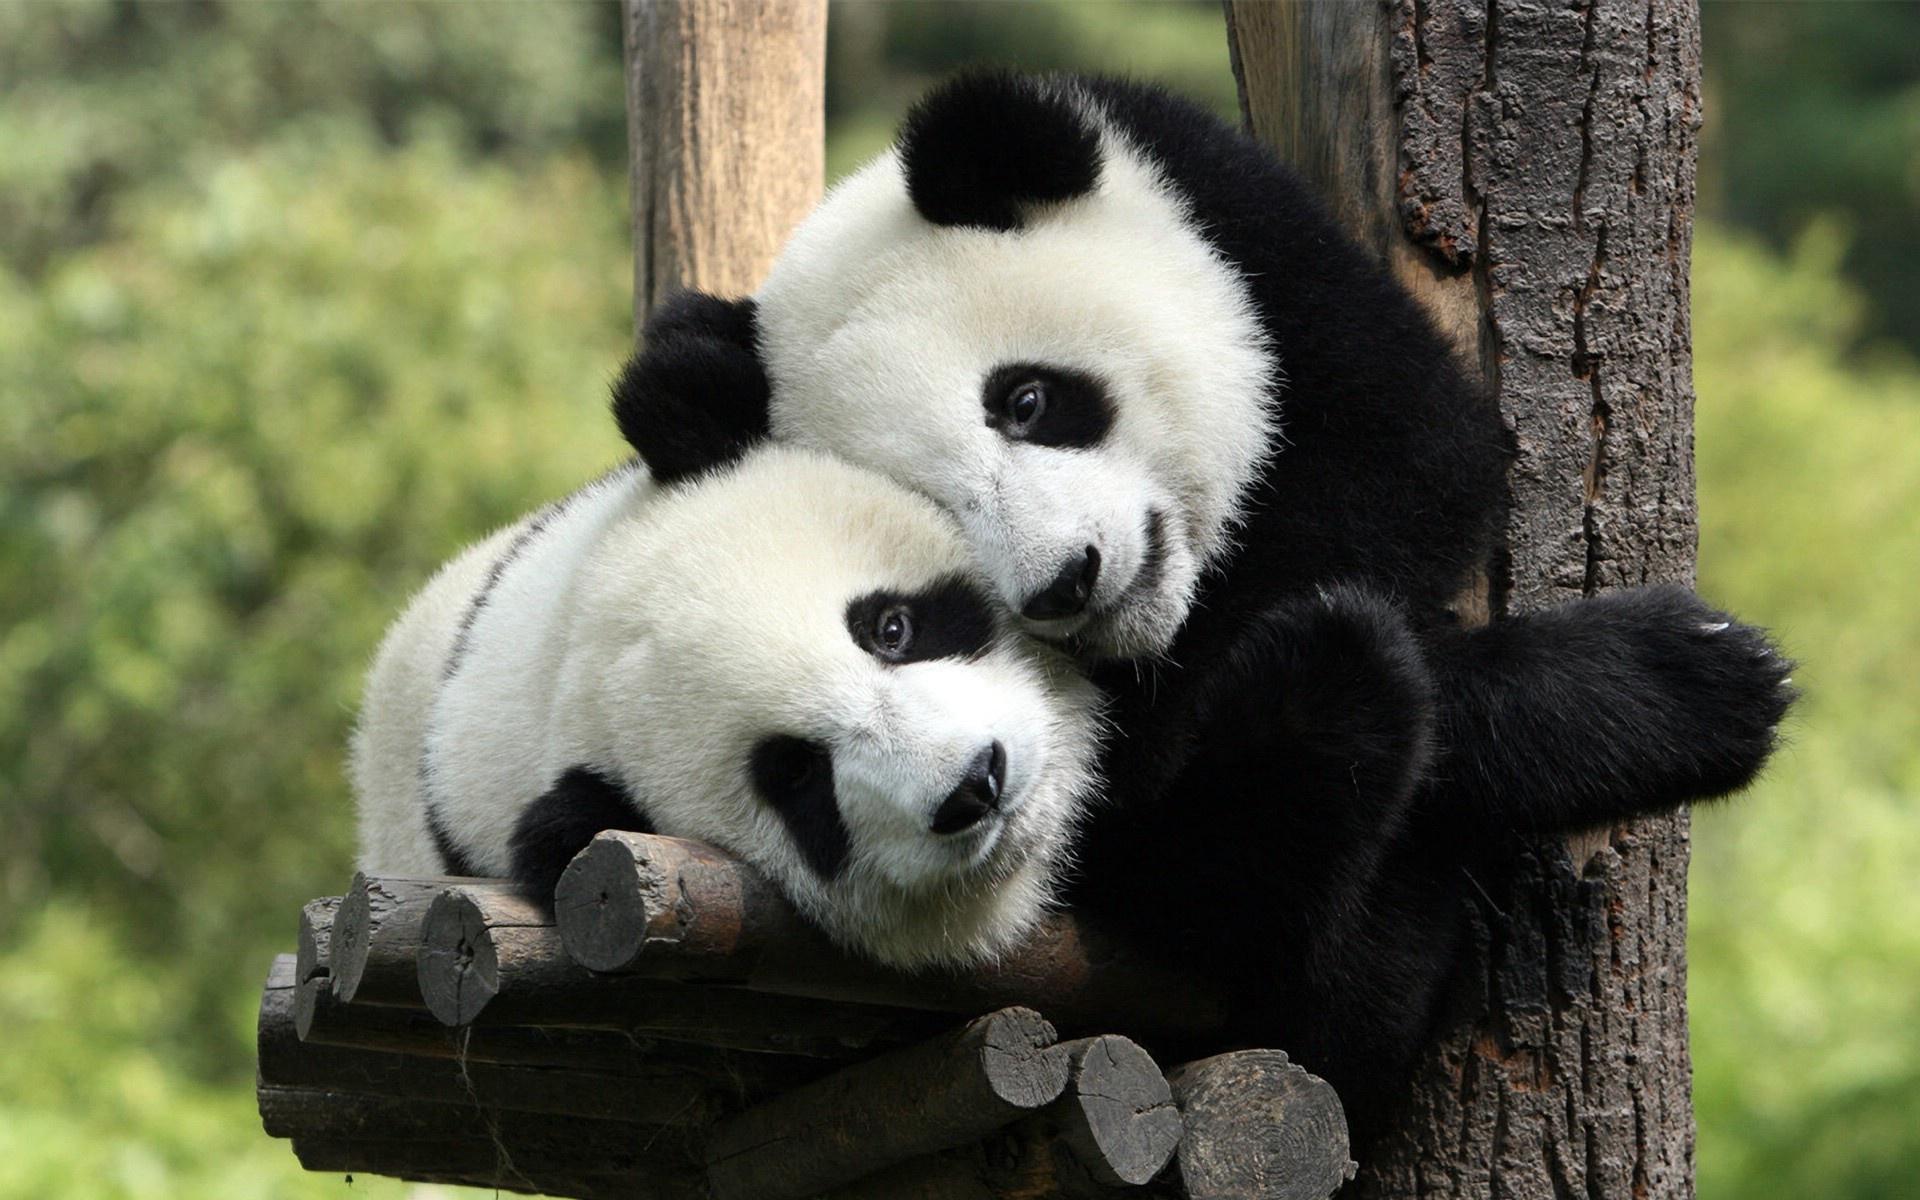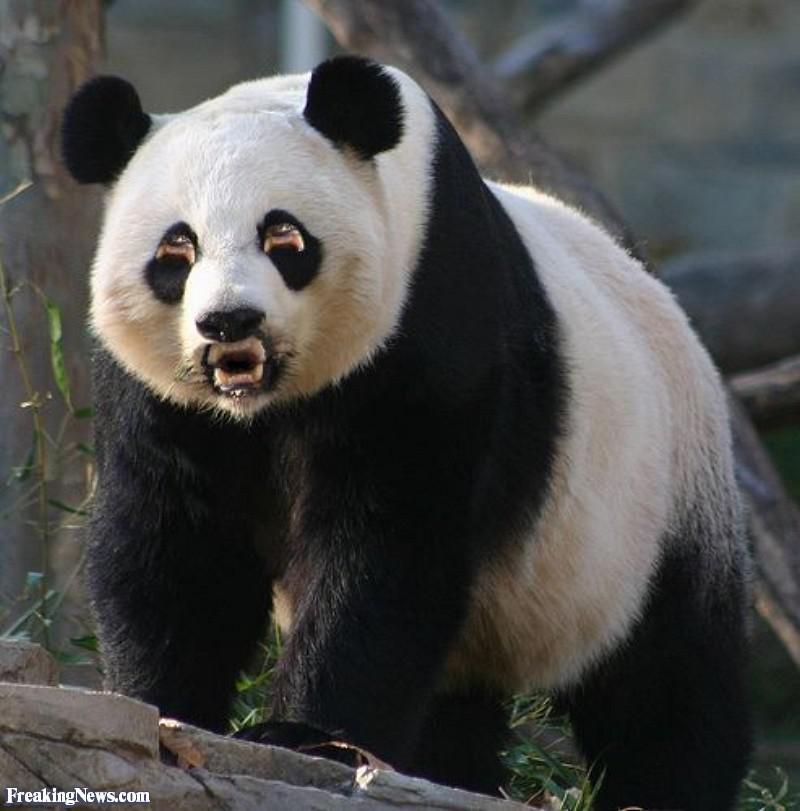The first image is the image on the left, the second image is the image on the right. Given the left and right images, does the statement "An image shows an adult panda on its back, playing with a young panda on top." hold true? Answer yes or no. No. 